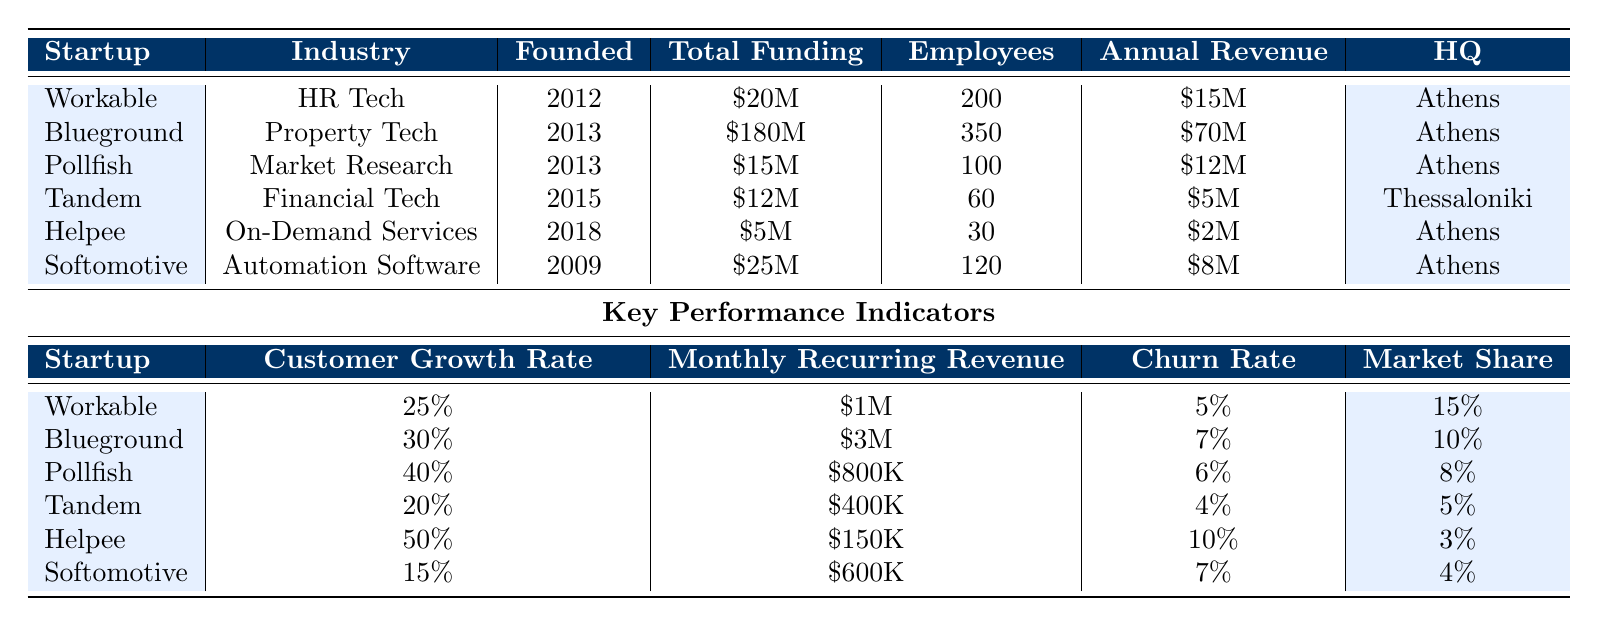What was the total funding amount for Blueground? The funding amount for Blueground is clearly listed in the table, and it shows \$180M.
Answer: \$180M Which startup has the highest annual revenue, and what is that revenue? By examining the annual revenue column, Blueground has the highest annual revenue at \$70M.
Answer: Blueground; \$70M What is the average churn rate of all the startups? To calculate the average churn rate, first sum the individual churn rates: (5% + 7% + 6% + 4% + 10% + 7%) = 39%. There are 6 startups, so the average is 39% / 6 ≈ 6.5%.
Answer: 6.5% Is Helpee's customer growth rate higher than Tandem's? From the customer growth rate column, Helpee has a growth rate of 50%, while Tandem has a growth rate of 20%. Since 50% is greater than 20%, the statement is true.
Answer: Yes Which startup has the lowest market share, and what is it? By checking the market share column values, Helpee has the lowest market share at 3%.
Answer: Helpee; 3% What is the total number of employees across all listed startups? Summing the employee counts: 200 (Workable) + 350 (Blueground) + 100 (Pollfish) + 60 (Tandem) + 30 (Helpee) + 120 (Softomotive) = 960 employees.
Answer: 960 Which industry has the second largest total funding, and how much is it? The total funding goes as follows: Blueground (\$180M), Softomotive (\$25M), Workable (\$20M), Pollfish (\$15M), Tandem (\$12M), Helpee (\$5M). Softomotive has the second largest funding at \$25M.
Answer: Softomotive; \$25M How many startups have a customer growth rate greater than 30%? The startups with a customer growth rate greater than 30% are Blueground (30%), Pollfish (40%), and Helpee (50%). There are 3 such startups.
Answer: 3 Which startup has the highest employee count, and how many employees are there? Looking at the employee count column, Blueground has the highest number of employees with 350.
Answer: Blueground; 350 